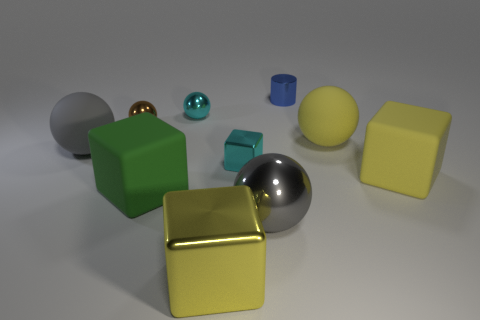Can you describe the different shapes and materials present in the scene? Certainly! The image showcases a variety of 3D geometric shapes with diverse surface properties. There's a green and a yellow cube, both exhibiting matte finishes. The cylinders come in blue and gray, the latter with a metallic sheen. We can also spot a shiny golden cube and a sphere with a chrome-like reflective surface. Tucked away towards the back is a smaller, possibly translucent sphere with a turquoise hue. 